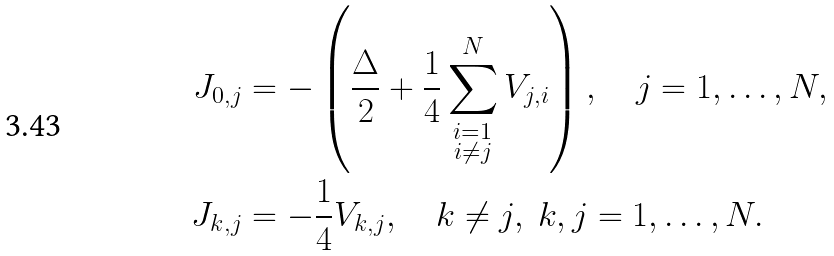Convert formula to latex. <formula><loc_0><loc_0><loc_500><loc_500>J _ { 0 , j } & = - \left ( \frac { \Delta } { 2 } + \frac { 1 } { 4 } \sum ^ { N } _ { \substack { i = 1 \\ i \neq j } } V _ { j , i } \right ) , \quad j = 1 , \dots , N , \\ J _ { k , j } & = - \frac { 1 } { 4 } V _ { k , j } , \quad k \neq j , \ k , j = 1 , \dots , N .</formula> 